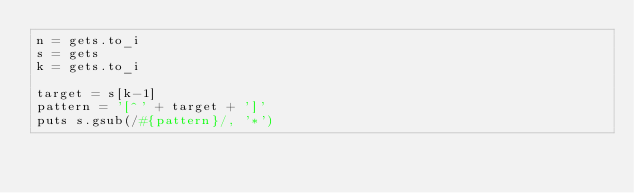<code> <loc_0><loc_0><loc_500><loc_500><_Ruby_>n = gets.to_i
s = gets
k = gets.to_i

target = s[k-1]
pattern = '[^' + target + ']'
puts s.gsub(/#{pattern}/, '*')</code> 